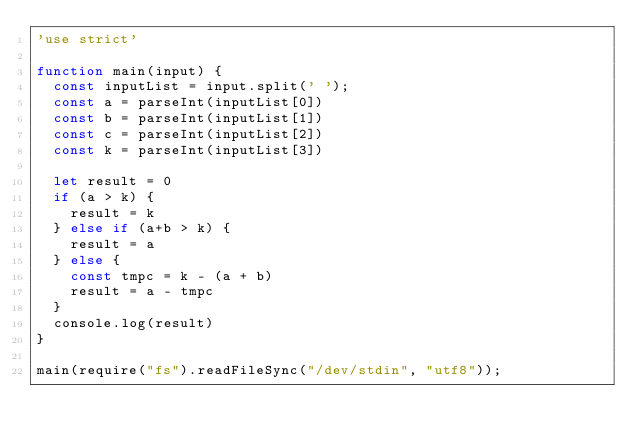Convert code to text. <code><loc_0><loc_0><loc_500><loc_500><_JavaScript_>'use strict'

function main(input) {
  const inputList = input.split(' ');
  const a = parseInt(inputList[0])
  const b = parseInt(inputList[1])
  const c = parseInt(inputList[2])
  const k = parseInt(inputList[3])

  let result = 0
  if (a > k) {
    result = k
  } else if (a+b > k) {
    result = a
  } else {
    const tmpc = k - (a + b)
    result = a - tmpc
  }
  console.log(result)
}

main(require("fs").readFileSync("/dev/stdin", "utf8"));</code> 